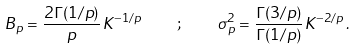Convert formula to latex. <formula><loc_0><loc_0><loc_500><loc_500>B _ { p } = \frac { 2 \Gamma ( 1 / p ) } { p } \, K ^ { - 1 / p } \quad ; \quad \sigma _ { p } ^ { 2 } = \frac { \Gamma ( 3 / p ) } { \Gamma ( 1 / p ) } \, K ^ { - 2 / p } \, .</formula> 